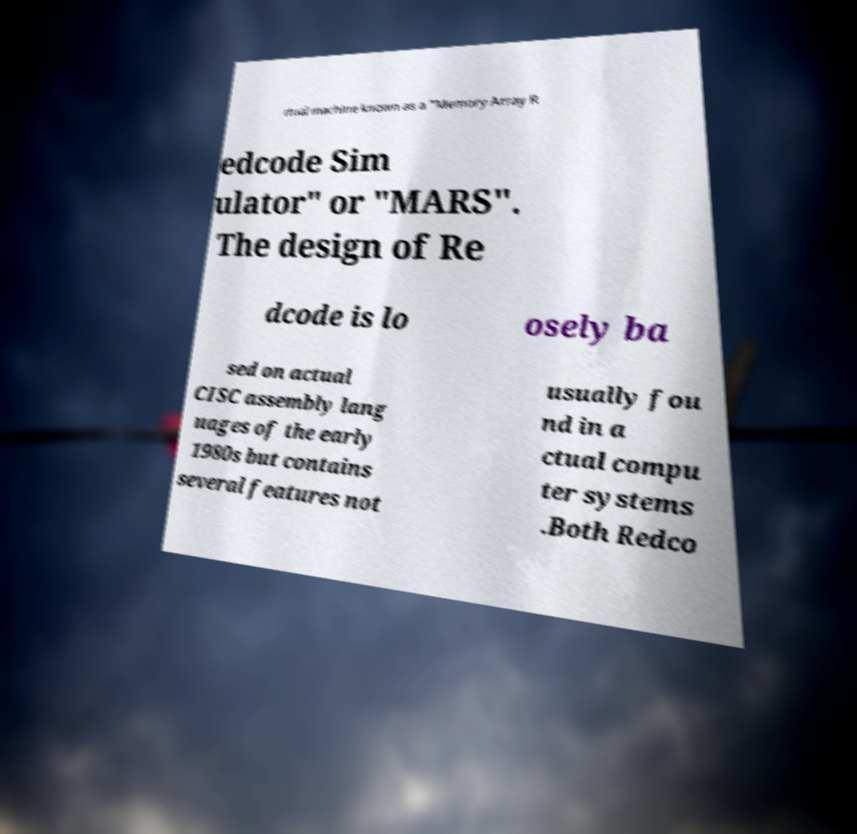Could you assist in decoding the text presented in this image and type it out clearly? rtual machine known as a "Memory Array R edcode Sim ulator" or "MARS". The design of Re dcode is lo osely ba sed on actual CISC assembly lang uages of the early 1980s but contains several features not usually fou nd in a ctual compu ter systems .Both Redco 